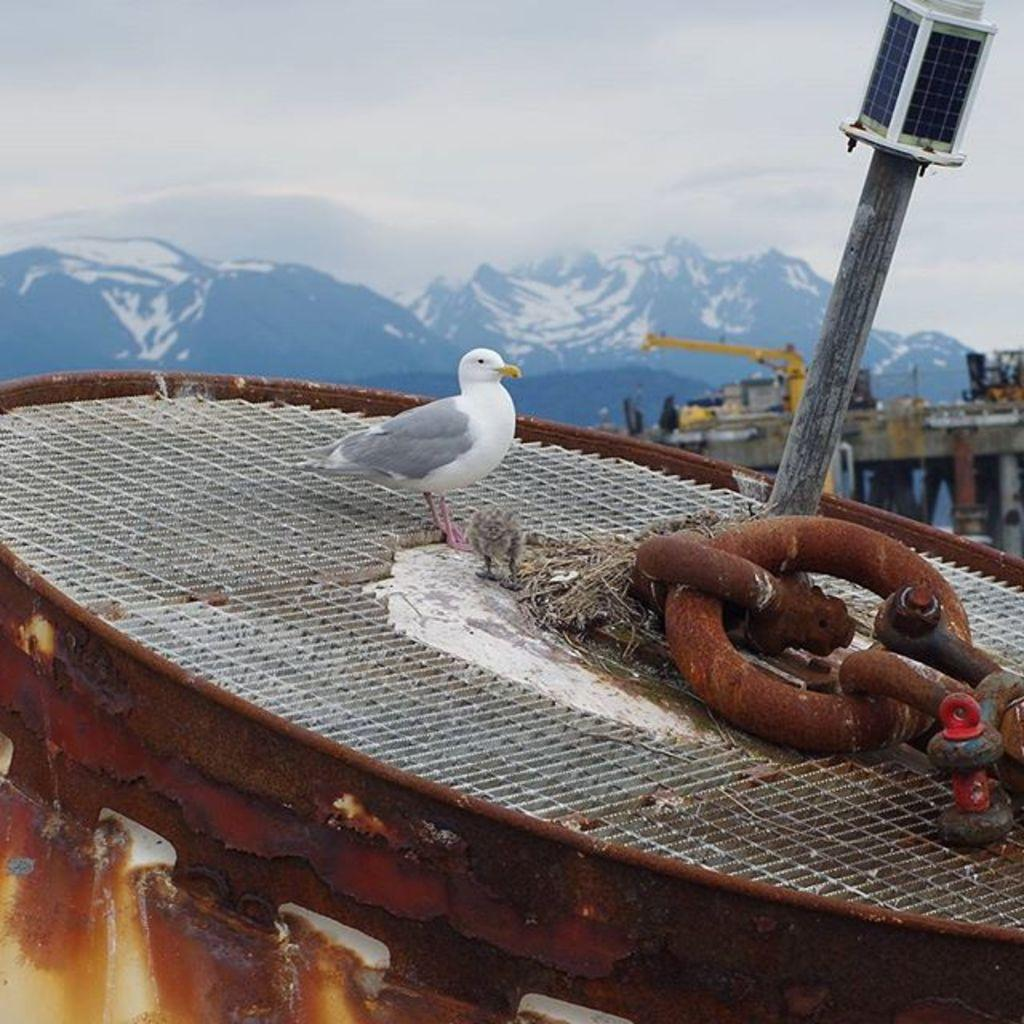What is the bird perched on in the image? The bird is on an object in the image. What can be seen on the bridge in the image? There are vehicles on a bridge in the image. What type of natural landscape is visible in the image? There are mountains visible in the image. What is the color of the sky in the image? The sky appears to be white in color. Can you see a cub playing with a jellyfish in the image? No, there is no cub or jellyfish present in the image. What level of respect is shown by the mountains in the image? The mountains do not display respect or any other emotions, as they are inanimate objects. 